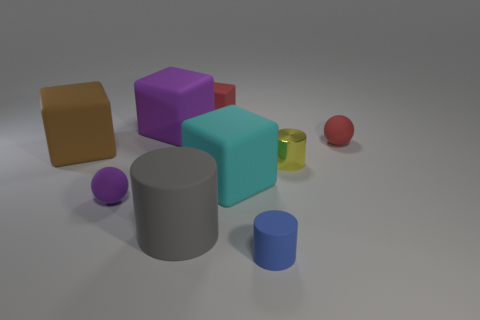Subtract all large purple cubes. How many cubes are left? 3 Subtract all cubes. How many objects are left? 5 Subtract all blue cylinders. How many cylinders are left? 2 Add 1 tiny red objects. How many objects exist? 10 Subtract 1 gray cylinders. How many objects are left? 8 Subtract 1 cylinders. How many cylinders are left? 2 Subtract all brown spheres. Subtract all gray cylinders. How many spheres are left? 2 Subtract all brown cubes. How many red cylinders are left? 0 Subtract all tiny rubber cylinders. Subtract all big rubber blocks. How many objects are left? 5 Add 1 blue rubber cylinders. How many blue rubber cylinders are left? 2 